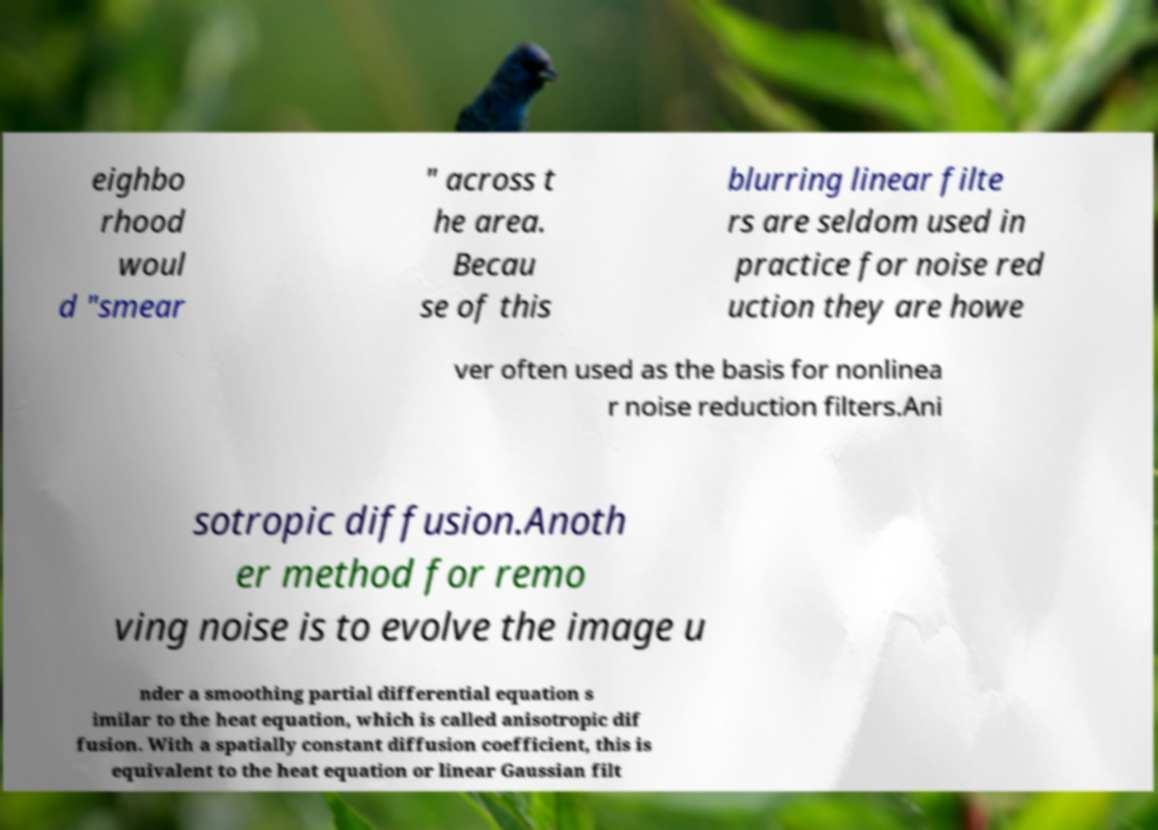Please identify and transcribe the text found in this image. eighbo rhood woul d "smear " across t he area. Becau se of this blurring linear filte rs are seldom used in practice for noise red uction they are howe ver often used as the basis for nonlinea r noise reduction filters.Ani sotropic diffusion.Anoth er method for remo ving noise is to evolve the image u nder a smoothing partial differential equation s imilar to the heat equation, which is called anisotropic dif fusion. With a spatially constant diffusion coefficient, this is equivalent to the heat equation or linear Gaussian filt 